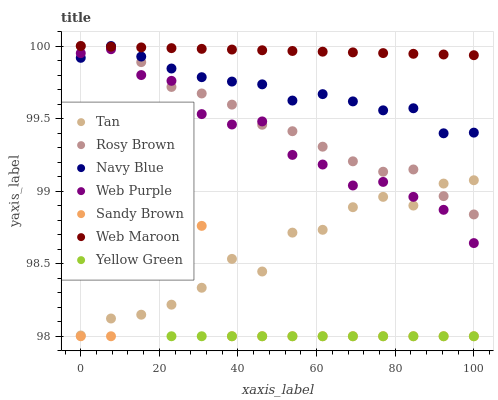Does Yellow Green have the minimum area under the curve?
Answer yes or no. Yes. Does Web Maroon have the maximum area under the curve?
Answer yes or no. Yes. Does Navy Blue have the minimum area under the curve?
Answer yes or no. No. Does Navy Blue have the maximum area under the curve?
Answer yes or no. No. Is Web Maroon the smoothest?
Answer yes or no. Yes. Is Sandy Brown the roughest?
Answer yes or no. Yes. Is Navy Blue the smoothest?
Answer yes or no. No. Is Navy Blue the roughest?
Answer yes or no. No. Does Yellow Green have the lowest value?
Answer yes or no. Yes. Does Navy Blue have the lowest value?
Answer yes or no. No. Does Web Maroon have the highest value?
Answer yes or no. Yes. Does Web Purple have the highest value?
Answer yes or no. No. Is Yellow Green less than Navy Blue?
Answer yes or no. Yes. Is Web Maroon greater than Yellow Green?
Answer yes or no. Yes. Does Rosy Brown intersect Web Maroon?
Answer yes or no. Yes. Is Rosy Brown less than Web Maroon?
Answer yes or no. No. Is Rosy Brown greater than Web Maroon?
Answer yes or no. No. Does Yellow Green intersect Navy Blue?
Answer yes or no. No. 